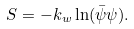Convert formula to latex. <formula><loc_0><loc_0><loc_500><loc_500>S = - k _ { w } \ln ( \bar { \psi } \psi ) .</formula> 